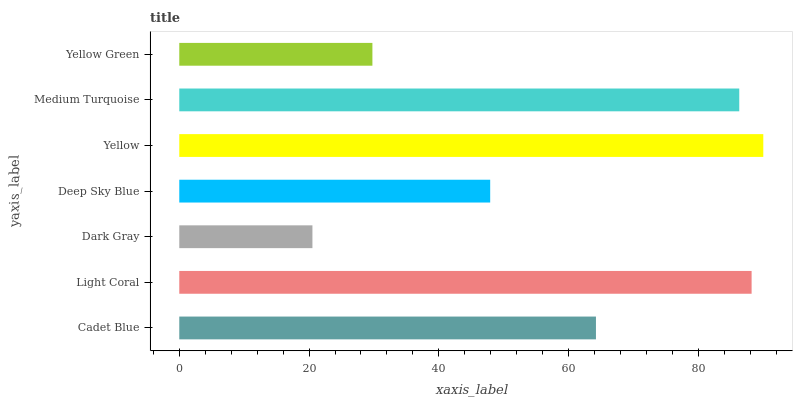Is Dark Gray the minimum?
Answer yes or no. Yes. Is Yellow the maximum?
Answer yes or no. Yes. Is Light Coral the minimum?
Answer yes or no. No. Is Light Coral the maximum?
Answer yes or no. No. Is Light Coral greater than Cadet Blue?
Answer yes or no. Yes. Is Cadet Blue less than Light Coral?
Answer yes or no. Yes. Is Cadet Blue greater than Light Coral?
Answer yes or no. No. Is Light Coral less than Cadet Blue?
Answer yes or no. No. Is Cadet Blue the high median?
Answer yes or no. Yes. Is Cadet Blue the low median?
Answer yes or no. Yes. Is Light Coral the high median?
Answer yes or no. No. Is Dark Gray the low median?
Answer yes or no. No. 